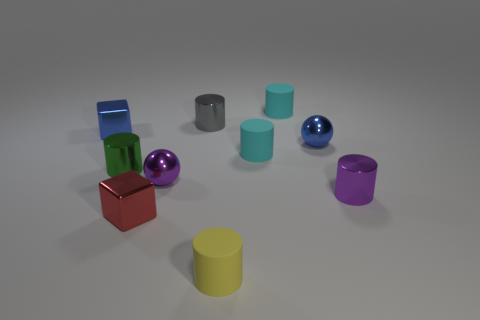Subtract 3 cylinders. How many cylinders are left? 3 Subtract all yellow cylinders. How many cylinders are left? 5 Subtract all green cylinders. How many cylinders are left? 5 Subtract all purple cylinders. Subtract all yellow cubes. How many cylinders are left? 5 Subtract all cylinders. How many objects are left? 4 Add 7 tiny matte cylinders. How many tiny matte cylinders exist? 10 Subtract 0 red balls. How many objects are left? 10 Subtract all small gray rubber objects. Subtract all metallic spheres. How many objects are left? 8 Add 6 small matte objects. How many small matte objects are left? 9 